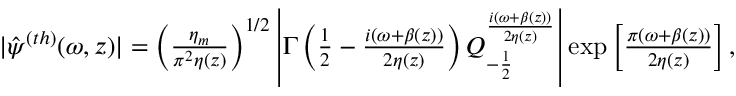Convert formula to latex. <formula><loc_0><loc_0><loc_500><loc_500>\begin{array} { r } { \, | \hat { \psi } ^ { ( t h ) } ( \omega , z ) | = \left ( \frac { \eta _ { m } } { \pi ^ { 2 } \eta ( z ) } \right ) ^ { 1 / 2 } \left | \Gamma \left ( \frac { 1 } { 2 } - \frac { i ( \omega + \beta ( z ) ) } { 2 \eta ( z ) } \right ) Q _ { - \frac { 1 } { 2 } } ^ { \frac { i ( \omega + \beta ( z ) ) } { 2 \eta ( z ) } } \right | \exp \left [ \frac { \pi ( \omega + \beta ( z ) ) } { 2 \eta ( z ) } \right ] , } \end{array}</formula> 